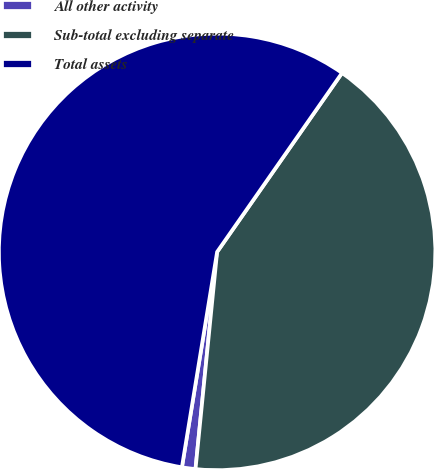<chart> <loc_0><loc_0><loc_500><loc_500><pie_chart><fcel>All other activity<fcel>Sub-total excluding separate<fcel>Total assets<nl><fcel>1.0%<fcel>41.88%<fcel>57.12%<nl></chart> 